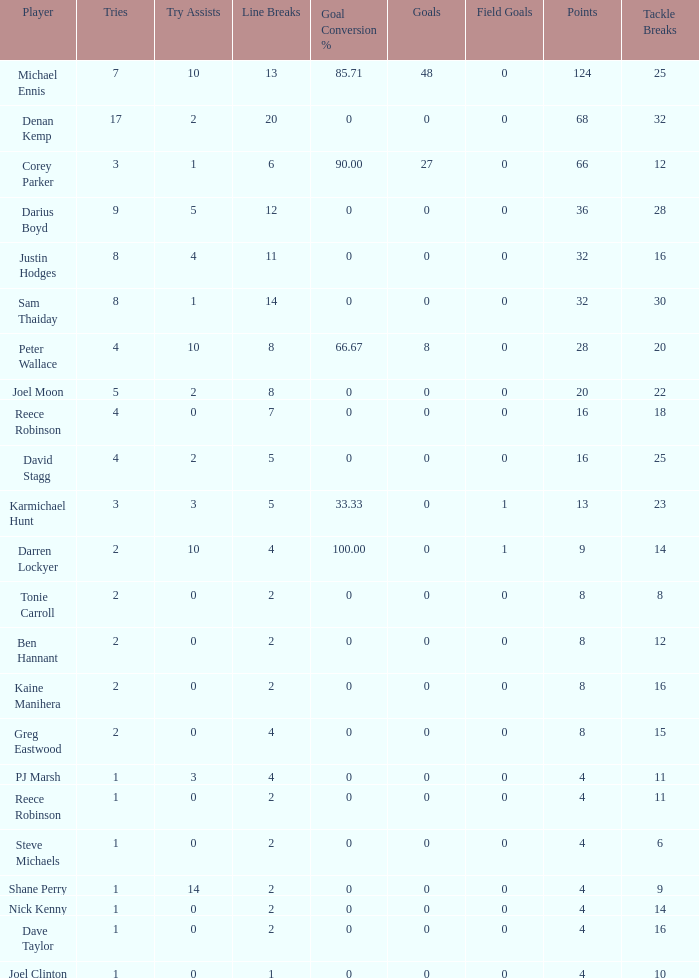What is the number of goals Dave Taylor, who has more than 1 tries, has? None. 